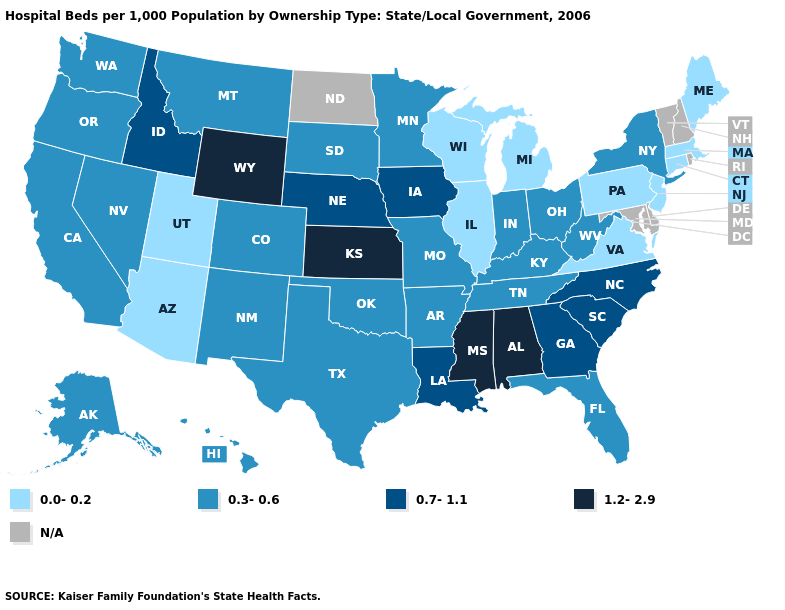Name the states that have a value in the range 0.0-0.2?
Quick response, please. Arizona, Connecticut, Illinois, Maine, Massachusetts, Michigan, New Jersey, Pennsylvania, Utah, Virginia, Wisconsin. What is the value of Wisconsin?
Short answer required. 0.0-0.2. Among the states that border Maryland , which have the highest value?
Answer briefly. West Virginia. Name the states that have a value in the range N/A?
Short answer required. Delaware, Maryland, New Hampshire, North Dakota, Rhode Island, Vermont. Name the states that have a value in the range 0.3-0.6?
Write a very short answer. Alaska, Arkansas, California, Colorado, Florida, Hawaii, Indiana, Kentucky, Minnesota, Missouri, Montana, Nevada, New Mexico, New York, Ohio, Oklahoma, Oregon, South Dakota, Tennessee, Texas, Washington, West Virginia. Does the first symbol in the legend represent the smallest category?
Give a very brief answer. Yes. What is the highest value in states that border New Jersey?
Quick response, please. 0.3-0.6. What is the highest value in states that border Rhode Island?
Keep it brief. 0.0-0.2. Name the states that have a value in the range 1.2-2.9?
Short answer required. Alabama, Kansas, Mississippi, Wyoming. Among the states that border Wisconsin , which have the lowest value?
Give a very brief answer. Illinois, Michigan. Does the first symbol in the legend represent the smallest category?
Short answer required. Yes. What is the value of South Carolina?
Be succinct. 0.7-1.1. Name the states that have a value in the range 0.0-0.2?
Answer briefly. Arizona, Connecticut, Illinois, Maine, Massachusetts, Michigan, New Jersey, Pennsylvania, Utah, Virginia, Wisconsin. What is the lowest value in the USA?
Write a very short answer. 0.0-0.2. 